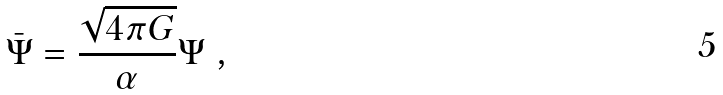Convert formula to latex. <formula><loc_0><loc_0><loc_500><loc_500>\bar { \Psi } = \frac { \sqrt { 4 \pi G } } { \alpha } \Psi \ ,</formula> 